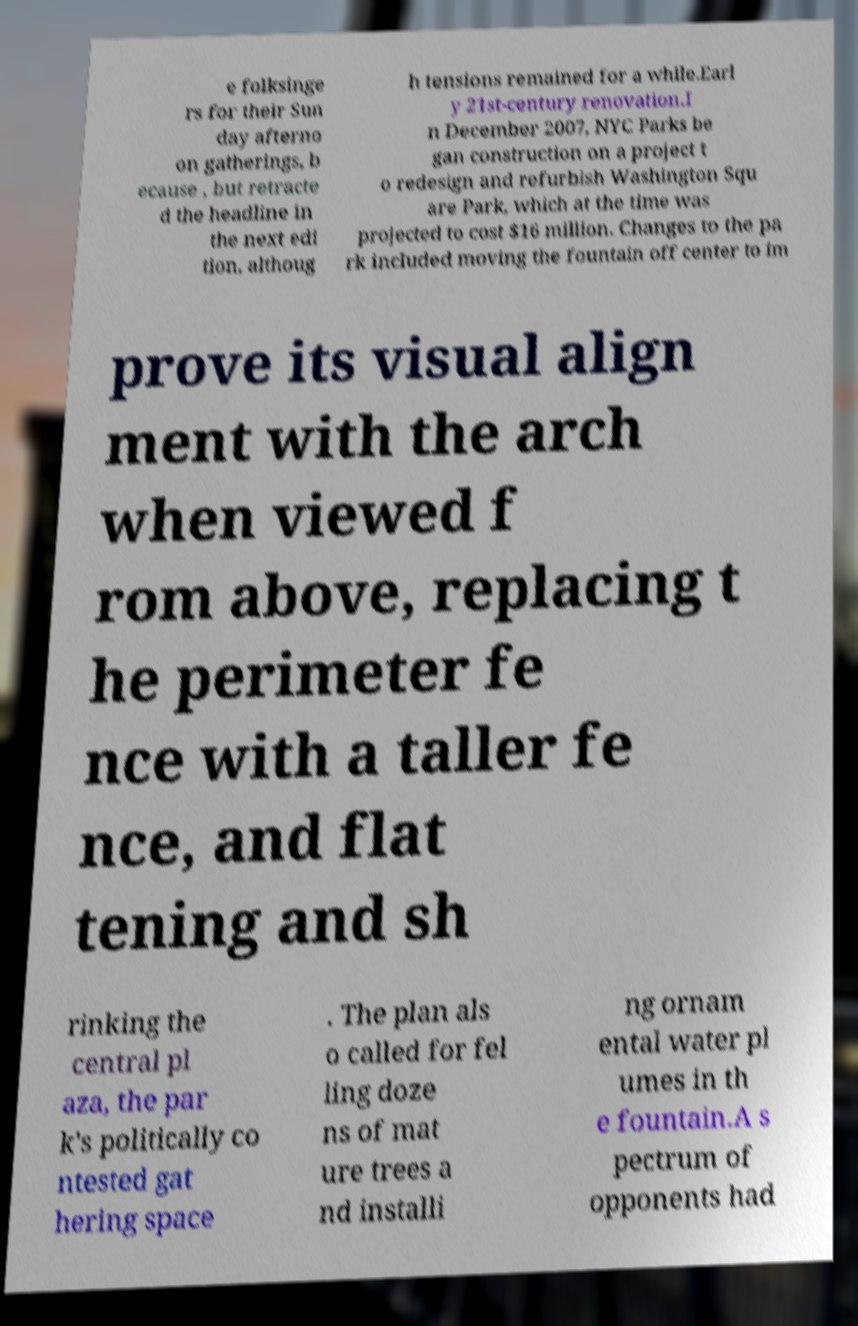Could you extract and type out the text from this image? e folksinge rs for their Sun day afterno on gatherings, b ecause , but retracte d the headline in the next edi tion, althoug h tensions remained for a while.Earl y 21st-century renovation.I n December 2007, NYC Parks be gan construction on a project t o redesign and refurbish Washington Squ are Park, which at the time was projected to cost $16 million. Changes to the pa rk included moving the fountain off center to im prove its visual align ment with the arch when viewed f rom above, replacing t he perimeter fe nce with a taller fe nce, and flat tening and sh rinking the central pl aza, the par k's politically co ntested gat hering space . The plan als o called for fel ling doze ns of mat ure trees a nd installi ng ornam ental water pl umes in th e fountain.A s pectrum of opponents had 